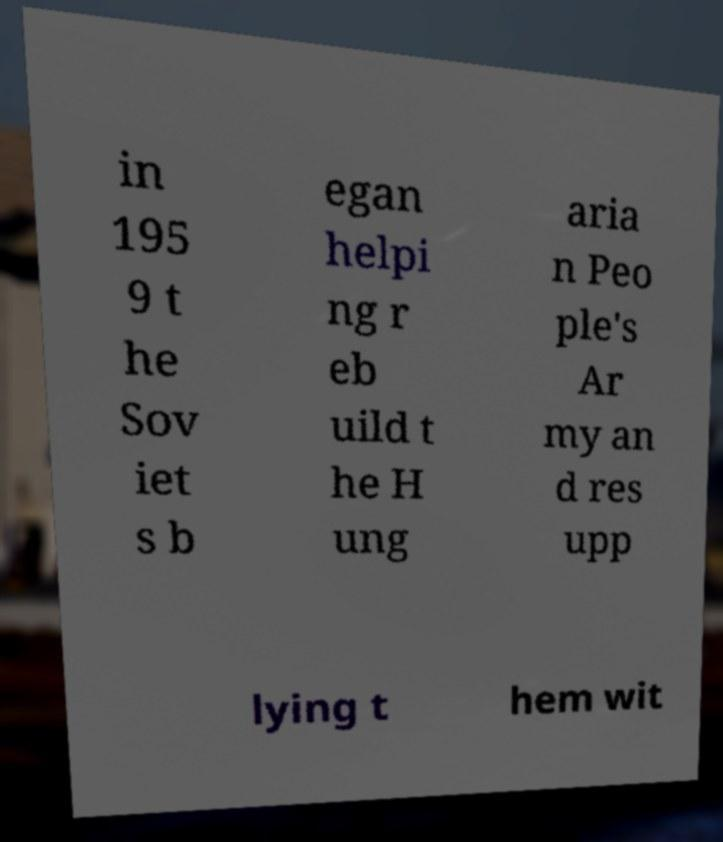Can you read and provide the text displayed in the image?This photo seems to have some interesting text. Can you extract and type it out for me? in 195 9 t he Sov iet s b egan helpi ng r eb uild t he H ung aria n Peo ple's Ar my an d res upp lying t hem wit 